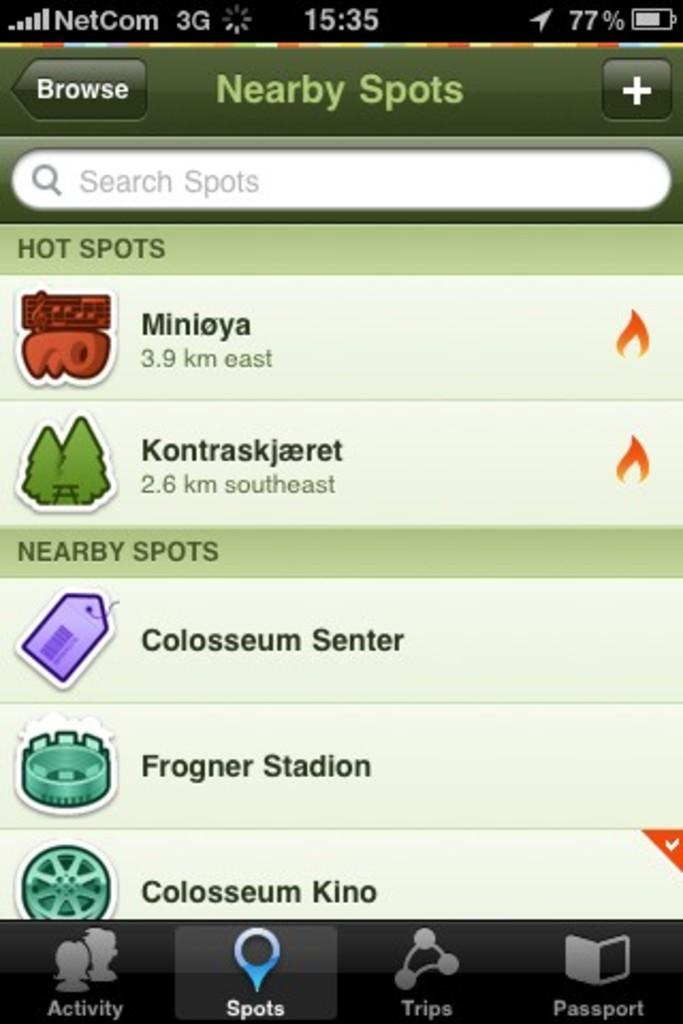<image>
Present a compact description of the photo's key features. some settings of nearby spots on the phone 